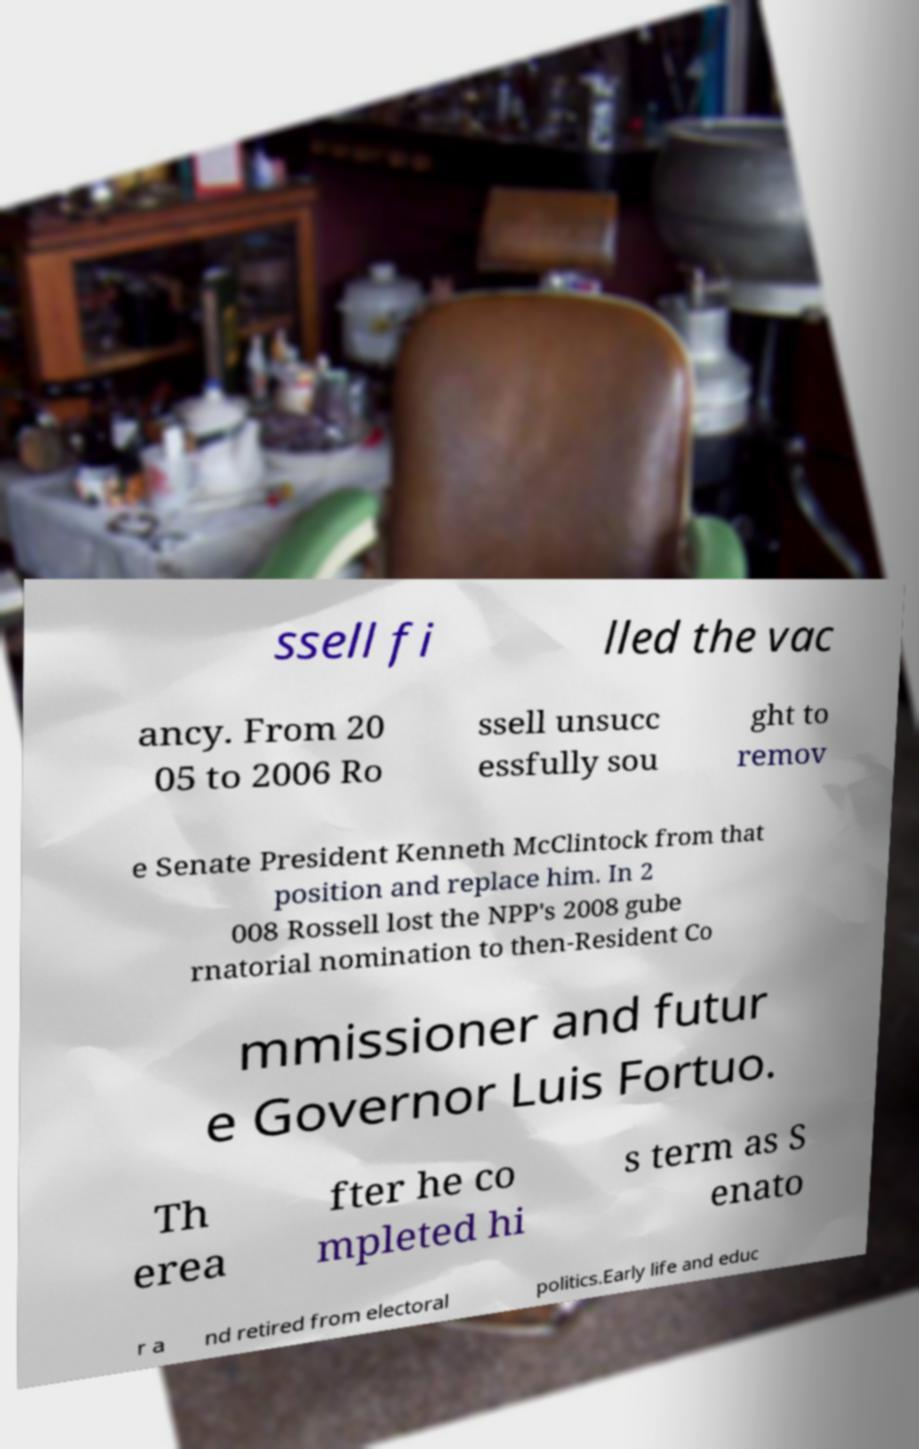Could you extract and type out the text from this image? ssell fi lled the vac ancy. From 20 05 to 2006 Ro ssell unsucc essfully sou ght to remov e Senate President Kenneth McClintock from that position and replace him. In 2 008 Rossell lost the NPP's 2008 gube rnatorial nomination to then-Resident Co mmissioner and futur e Governor Luis Fortuo. Th erea fter he co mpleted hi s term as S enato r a nd retired from electoral politics.Early life and educ 